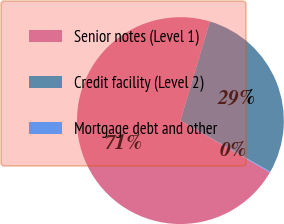Convert chart. <chart><loc_0><loc_0><loc_500><loc_500><pie_chart><fcel>Senior notes (Level 1)<fcel>Credit facility (Level 2)<fcel>Mortgage debt and other<nl><fcel>71.25%<fcel>28.63%<fcel>0.12%<nl></chart> 